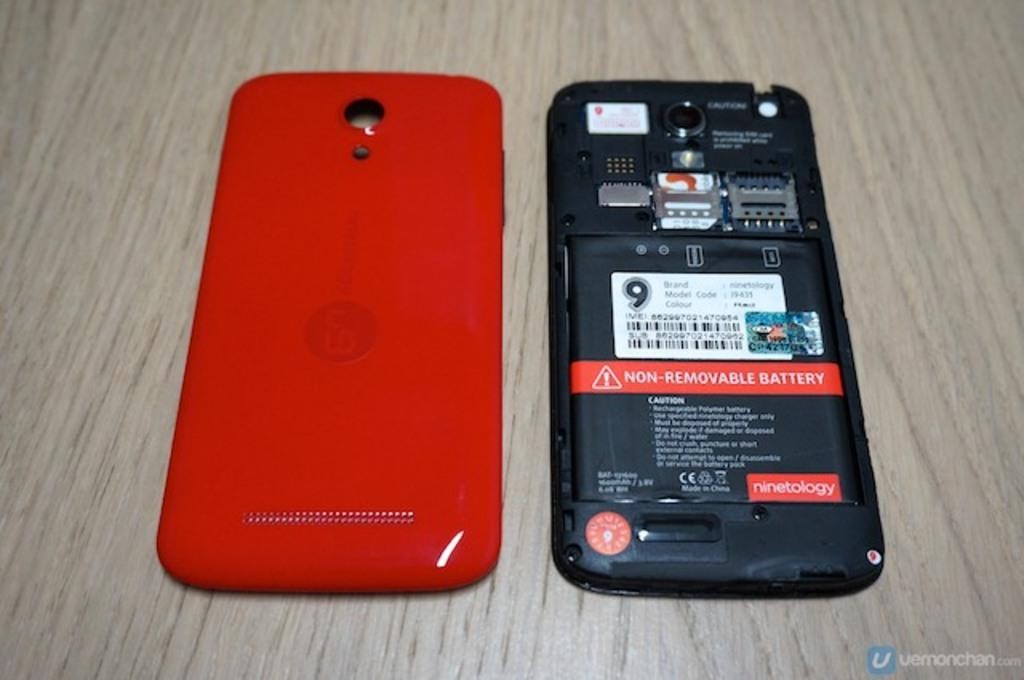What electronic device is visible in the image? There is a mobile phone in the image. What is the state of the mobile phone in the image? The back panel of the mobile phone is opened. What direction is the airport in the image? There is no airport present in the image, so it is not possible to determine the direction. 